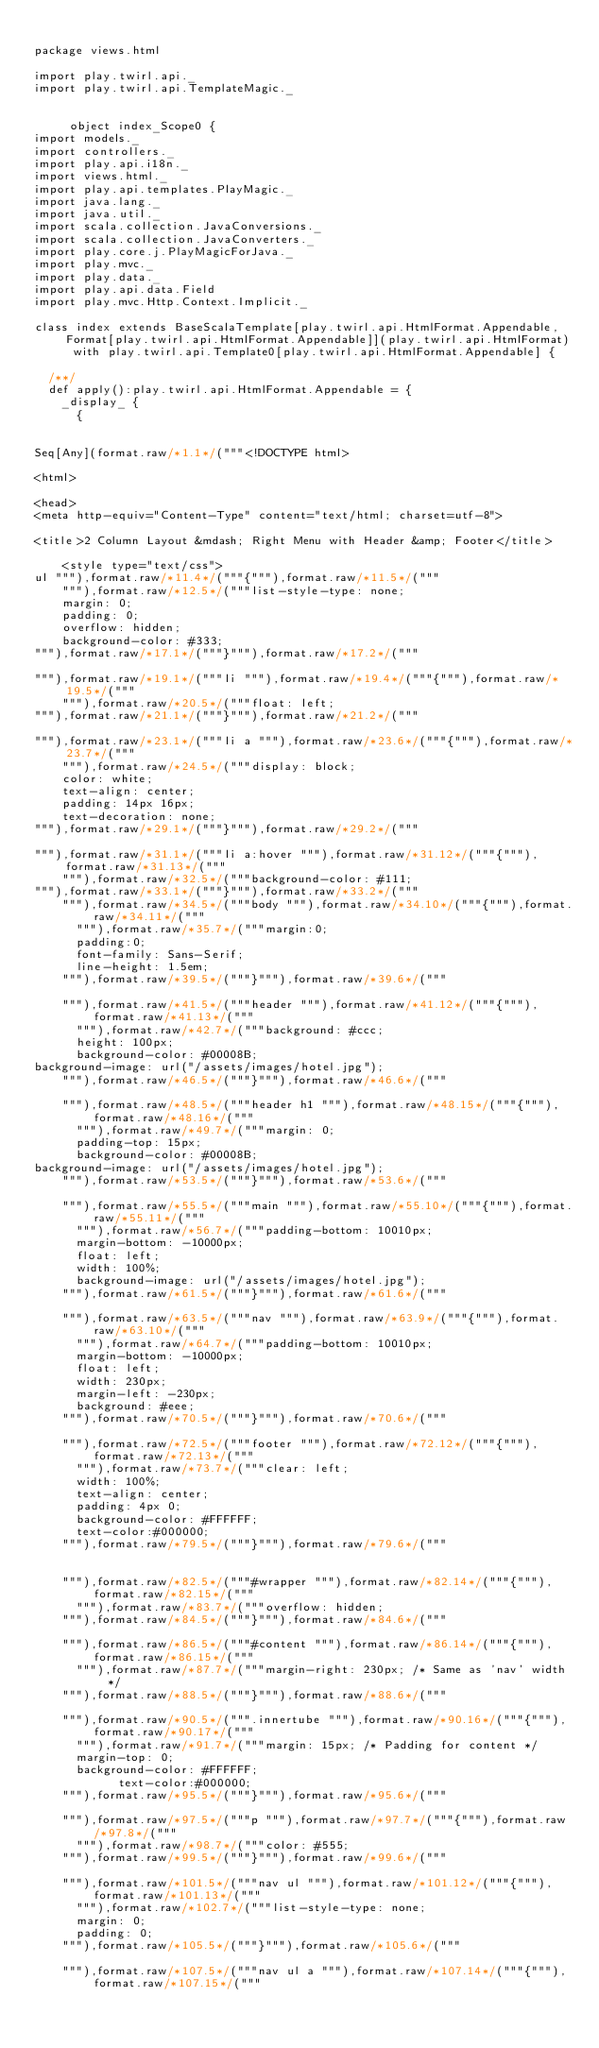Convert code to text. <code><loc_0><loc_0><loc_500><loc_500><_Scala_>
package views.html

import play.twirl.api._
import play.twirl.api.TemplateMagic._


     object index_Scope0 {
import models._
import controllers._
import play.api.i18n._
import views.html._
import play.api.templates.PlayMagic._
import java.lang._
import java.util._
import scala.collection.JavaConversions._
import scala.collection.JavaConverters._
import play.core.j.PlayMagicForJava._
import play.mvc._
import play.data._
import play.api.data.Field
import play.mvc.Http.Context.Implicit._

class index extends BaseScalaTemplate[play.twirl.api.HtmlFormat.Appendable,Format[play.twirl.api.HtmlFormat.Appendable]](play.twirl.api.HtmlFormat) with play.twirl.api.Template0[play.twirl.api.HtmlFormat.Appendable] {

  /**/
  def apply():play.twirl.api.HtmlFormat.Appendable = {
    _display_ {
      {


Seq[Any](format.raw/*1.1*/("""<!DOCTYPE html>

<html>
    
<head>
<meta http-equiv="Content-Type" content="text/html; charset=utf-8">
        
<title>2 Column Layout &mdash; Right Menu with Header &amp; Footer</title>
        
    <style type="text/css">
ul """),format.raw/*11.4*/("""{"""),format.raw/*11.5*/("""
    """),format.raw/*12.5*/("""list-style-type: none;
    margin: 0;
    padding: 0;
    overflow: hidden;
    background-color: #333;
"""),format.raw/*17.1*/("""}"""),format.raw/*17.2*/("""

"""),format.raw/*19.1*/("""li """),format.raw/*19.4*/("""{"""),format.raw/*19.5*/("""
    """),format.raw/*20.5*/("""float: left;
"""),format.raw/*21.1*/("""}"""),format.raw/*21.2*/("""

"""),format.raw/*23.1*/("""li a """),format.raw/*23.6*/("""{"""),format.raw/*23.7*/("""
    """),format.raw/*24.5*/("""display: block;
    color: white;
    text-align: center;
    padding: 14px 16px;
    text-decoration: none;
"""),format.raw/*29.1*/("""}"""),format.raw/*29.2*/("""

"""),format.raw/*31.1*/("""li a:hover """),format.raw/*31.12*/("""{"""),format.raw/*31.13*/("""
    """),format.raw/*32.5*/("""background-color: #111;
"""),format.raw/*33.1*/("""}"""),format.raw/*33.2*/("""
    """),format.raw/*34.5*/("""body """),format.raw/*34.10*/("""{"""),format.raw/*34.11*/("""
      """),format.raw/*35.7*/("""margin:0;
      padding:0;
      font-family: Sans-Serif;
      line-height: 1.5em;
    """),format.raw/*39.5*/("""}"""),format.raw/*39.6*/("""

    """),format.raw/*41.5*/("""header """),format.raw/*41.12*/("""{"""),format.raw/*41.13*/("""
      """),format.raw/*42.7*/("""background: #ccc;
      height: 100px;
      background-color: #00008B;
background-image: url("/assets/images/hotel.jpg");
    """),format.raw/*46.5*/("""}"""),format.raw/*46.6*/("""

    """),format.raw/*48.5*/("""header h1 """),format.raw/*48.15*/("""{"""),format.raw/*48.16*/("""
      """),format.raw/*49.7*/("""margin: 0;
      padding-top: 15px;
      background-color: #00008B;
background-image: url("/assets/images/hotel.jpg");
    """),format.raw/*53.5*/("""}"""),format.raw/*53.6*/("""

    """),format.raw/*55.5*/("""main """),format.raw/*55.10*/("""{"""),format.raw/*55.11*/("""
      """),format.raw/*56.7*/("""padding-bottom: 10010px;
      margin-bottom: -10000px;
      float: left;
      width: 100%;
      background-image: url("/assets/images/hotel.jpg");
    """),format.raw/*61.5*/("""}"""),format.raw/*61.6*/("""

    """),format.raw/*63.5*/("""nav """),format.raw/*63.9*/("""{"""),format.raw/*63.10*/("""
      """),format.raw/*64.7*/("""padding-bottom: 10010px;
      margin-bottom: -10000px;
      float: left;
      width: 230px;
      margin-left: -230px;
      background: #eee;
    """),format.raw/*70.5*/("""}"""),format.raw/*70.6*/("""

    """),format.raw/*72.5*/("""footer """),format.raw/*72.12*/("""{"""),format.raw/*72.13*/("""
      """),format.raw/*73.7*/("""clear: left;
      width: 100%;
      text-align: center;
      padding: 4px 0;
      background-color: #FFFFFF;
      text-color:#000000;
    """),format.raw/*79.5*/("""}"""),format.raw/*79.6*/("""


    """),format.raw/*82.5*/("""#wrapper """),format.raw/*82.14*/("""{"""),format.raw/*82.15*/("""
      """),format.raw/*83.7*/("""overflow: hidden;
    """),format.raw/*84.5*/("""}"""),format.raw/*84.6*/("""

    """),format.raw/*86.5*/("""#content """),format.raw/*86.14*/("""{"""),format.raw/*86.15*/("""
      """),format.raw/*87.7*/("""margin-right: 230px; /* Same as 'nav' width */
    """),format.raw/*88.5*/("""}"""),format.raw/*88.6*/("""

    """),format.raw/*90.5*/(""".innertube """),format.raw/*90.16*/("""{"""),format.raw/*90.17*/("""
      """),format.raw/*91.7*/("""margin: 15px; /* Padding for content */
      margin-top: 0;
      background-color: #FFFFFF;
            text-color:#000000;
    """),format.raw/*95.5*/("""}"""),format.raw/*95.6*/("""

    """),format.raw/*97.5*/("""p """),format.raw/*97.7*/("""{"""),format.raw/*97.8*/("""
      """),format.raw/*98.7*/("""color: #555;
    """),format.raw/*99.5*/("""}"""),format.raw/*99.6*/("""

    """),format.raw/*101.5*/("""nav ul """),format.raw/*101.12*/("""{"""),format.raw/*101.13*/("""
      """),format.raw/*102.7*/("""list-style-type: none;
      margin: 0;
      padding: 0;
    """),format.raw/*105.5*/("""}"""),format.raw/*105.6*/("""

    """),format.raw/*107.5*/("""nav ul a """),format.raw/*107.14*/("""{"""),format.raw/*107.15*/("""</code> 